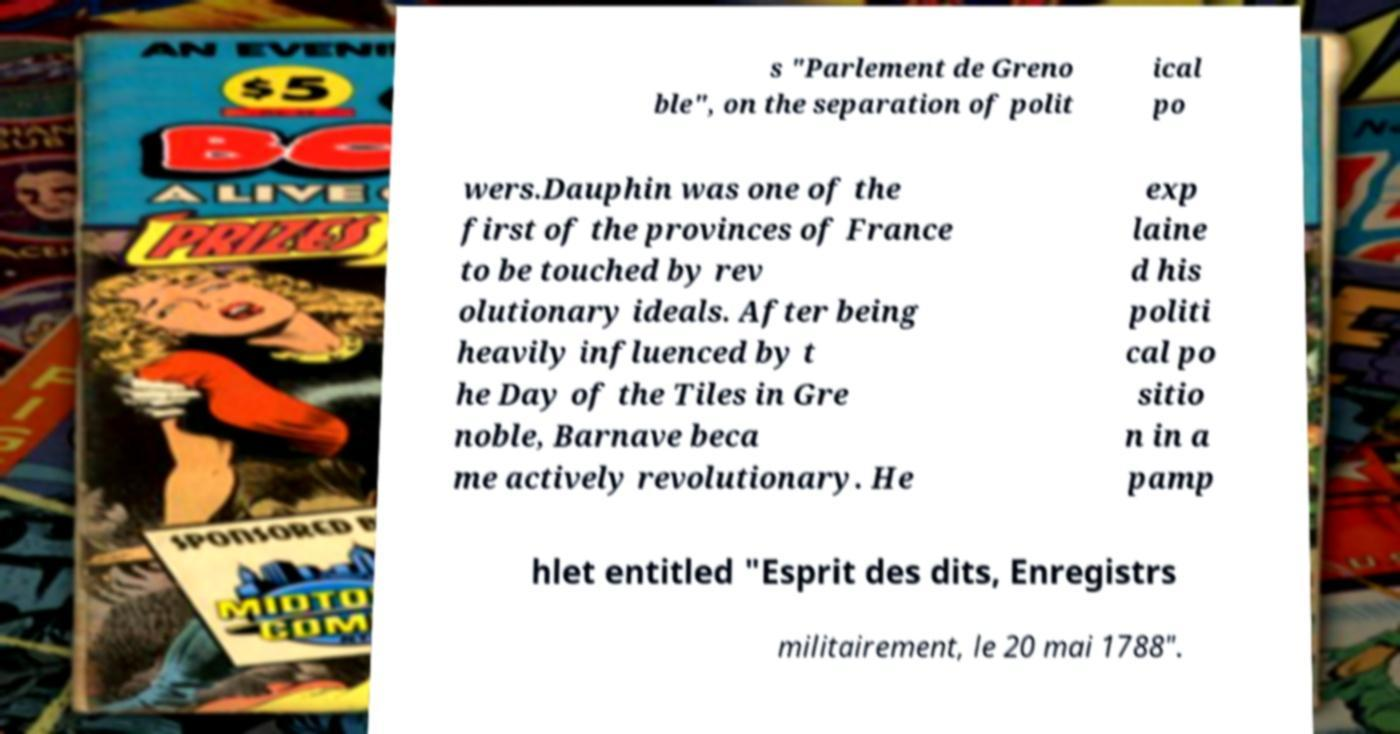Could you assist in decoding the text presented in this image and type it out clearly? s "Parlement de Greno ble", on the separation of polit ical po wers.Dauphin was one of the first of the provinces of France to be touched by rev olutionary ideals. After being heavily influenced by t he Day of the Tiles in Gre noble, Barnave beca me actively revolutionary. He exp laine d his politi cal po sitio n in a pamp hlet entitled "Esprit des dits, Enregistrs militairement, le 20 mai 1788". 